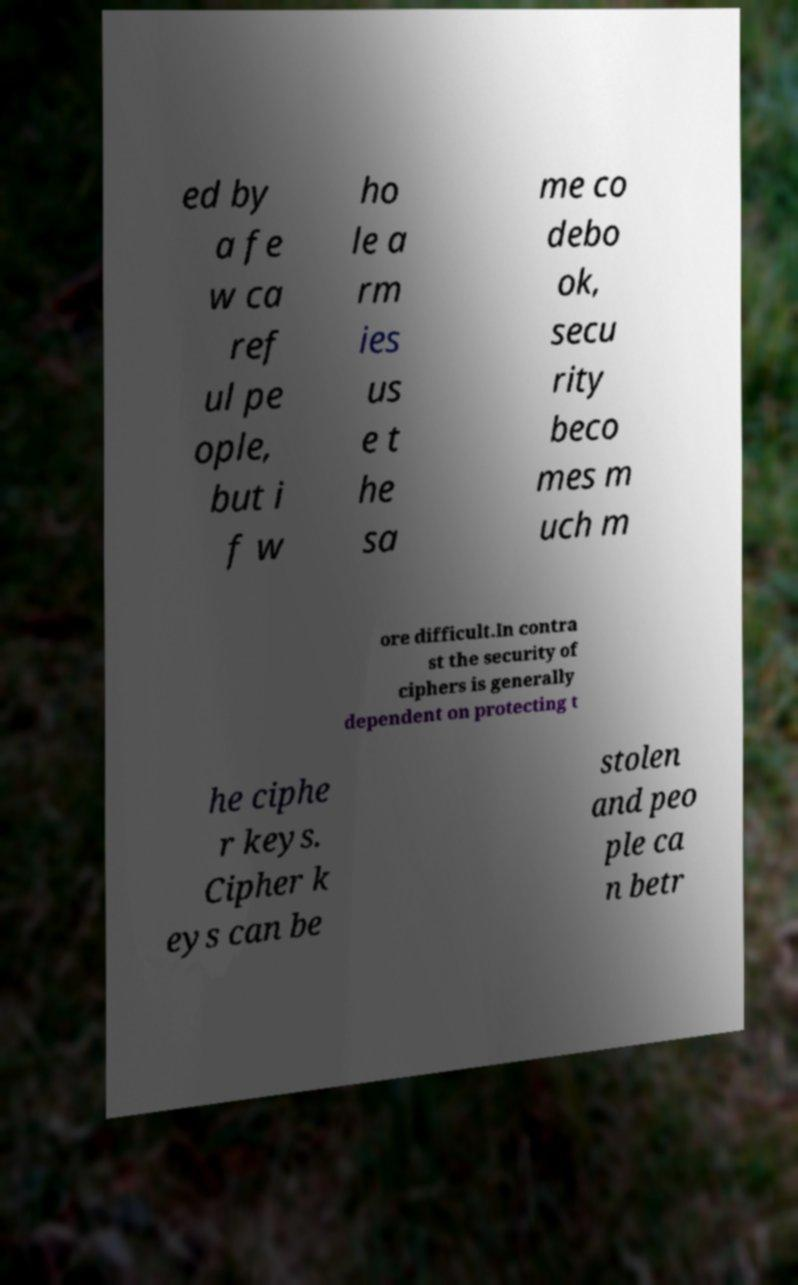What messages or text are displayed in this image? I need them in a readable, typed format. ed by a fe w ca ref ul pe ople, but i f w ho le a rm ies us e t he sa me co debo ok, secu rity beco mes m uch m ore difficult.In contra st the security of ciphers is generally dependent on protecting t he ciphe r keys. Cipher k eys can be stolen and peo ple ca n betr 